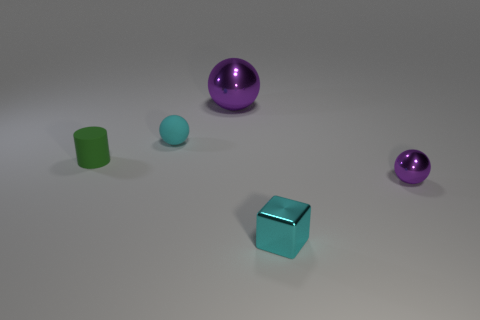Add 5 big spheres. How many objects exist? 10 Subtract all metal balls. How many balls are left? 1 Subtract 0 red balls. How many objects are left? 5 Subtract all blocks. How many objects are left? 4 Subtract 2 balls. How many balls are left? 1 Subtract all gray spheres. Subtract all purple cylinders. How many spheres are left? 3 Subtract all green spheres. How many red blocks are left? 0 Subtract all cyan spheres. Subtract all tiny shiny blocks. How many objects are left? 3 Add 3 metal blocks. How many metal blocks are left? 4 Add 3 large red cylinders. How many large red cylinders exist? 3 